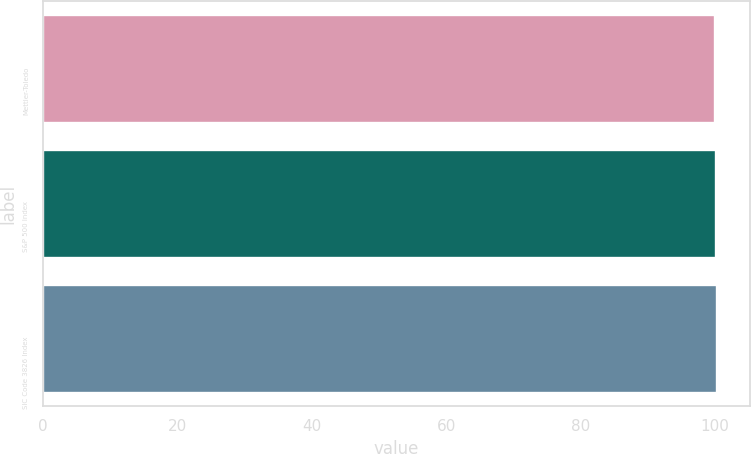Convert chart to OTSL. <chart><loc_0><loc_0><loc_500><loc_500><bar_chart><fcel>Mettler-Toledo<fcel>S&P 500 Index<fcel>SIC Code 3826 Index<nl><fcel>100<fcel>100.1<fcel>100.2<nl></chart> 